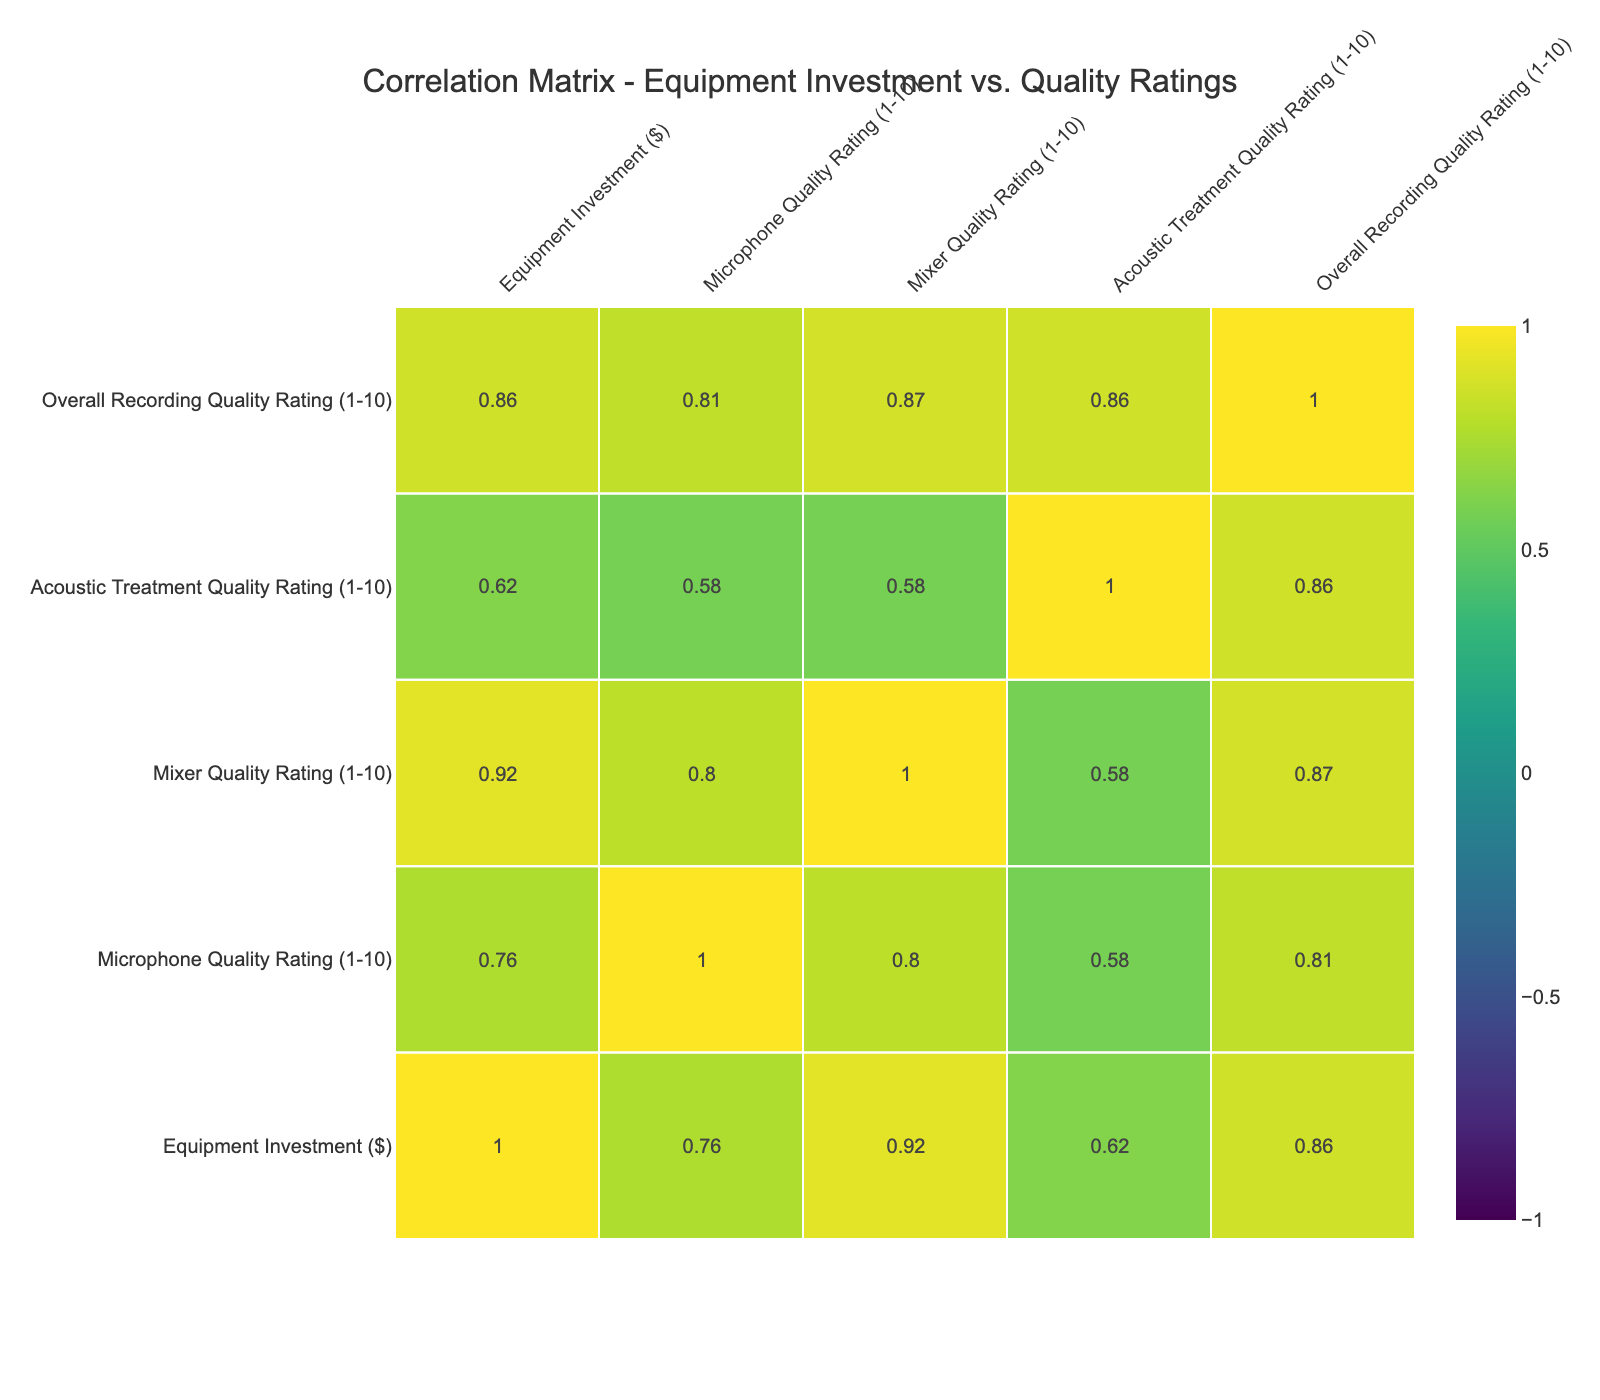What is the equipment investment of Urban Sound Lab? Urban Sound Lab has an equipment investment of 25000. The value can be found directly in the "Equipment Investment ($)" column next to the studio name.
Answer: 25000 What is the Overall Recording Quality Rating for Golden Records? The Overall Recording Quality Rating for Golden Records is 10. This is the value aligned with Golden Records in the "Overall Recording Quality Rating (1-10)" column.
Answer: 10 Is there a correlation between Equipment Investment and Overall Recording Quality Rating? Yes, there is a positive correlation between Equipment Investment and Overall Recording Quality Rating as indicated by the values in the correlation matrix, showing a relationship where higher investments lead to higher ratings.
Answer: Yes Which studio has the highest Microphone Quality Rating? Urban Sound Lab, Echo Chamber, and Golden Records each have the highest Microphone Quality Rating of 10. This information can be observed in the "Microphone Quality Rating (1-10)" column, where these studios are listed.
Answer: Urban Sound Lab, Echo Chamber, Golden Records What is the average Acoustic Treatment Quality Rating across all studios? The Acoustic Treatment Quality Ratings are 7, 8, 6, 9, 10, 9, 8, 7, 6, and 9. Adding these together gives 80, and dividing by 10 (the total number of studios) results in an average of 8.
Answer: 8 Does Melody Maker Studio have a quality rating higher than 8 in any category? No, Melody Maker Studio does not have a quality rating higher than 8 in any category, as its ratings are 7 for Microphone Quality, 8 for Mixer Quality, and 8 for Acoustic Treatment. Hence, all ratings are 8 or lower.
Answer: No What is the difference in Overall Recording Quality Rating between Urban Sound Lab and City Vibes Studio? Urban Sound Lab has an Overall Recording Quality Rating of 10 and City Vibes Studio has a rating of 7. The difference is calculated as 10 - 7, which equals 3.
Answer: 3 How does the Acoustic Treatment Quality Rating of Echo Chamber compare to that of Rhythm Nest? Echo Chamber has an Acoustic Treatment Quality Rating of 8, while Rhythm Nest has a rating of 9. Therefore, Rhythm Nest has a higher rating than Echo Chamber by 1 point.
Answer: Rhythm Nest has a higher rating Which studio has the lowest equipment investment and what is the value? City Vibes Studio has the lowest equipment investment of 12000. This can be determined by comparing the values in the "Equipment Investment ($)" column, identifying the minimum value.
Answer: 12000 